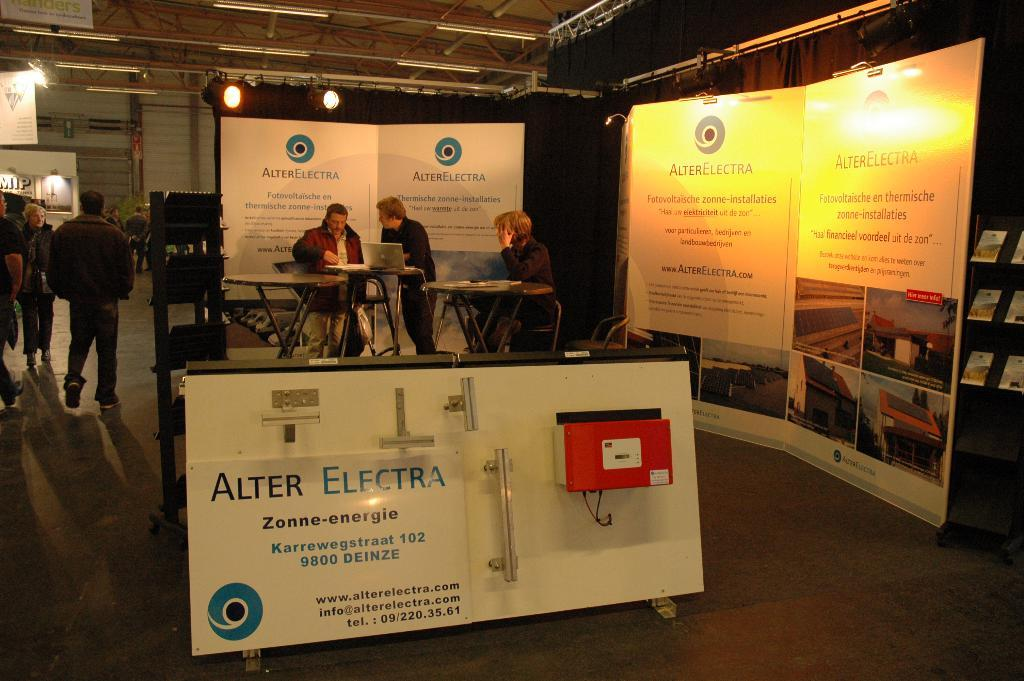What are the people in the image doing? Some people are sitting, and some are walking in the image. What objects can be seen in the image? There are boards, lights, a curtain, a wall, and rods visible in the image. Can you describe the background of the image? There is a curtain and a wall in the background of the image. What type of wing is visible in the image? There is no wing present in the image. How many curtains are visible in the image? There is only one curtain visible in the image. 